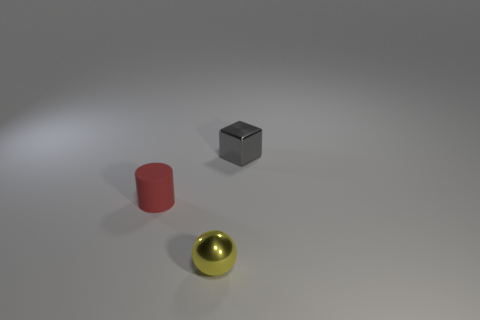Add 2 tiny metallic things. How many objects exist? 5 Subtract all balls. How many objects are left? 2 Subtract all large rubber blocks. Subtract all red things. How many objects are left? 2 Add 1 blocks. How many blocks are left? 2 Add 1 yellow shiny objects. How many yellow shiny objects exist? 2 Subtract 1 yellow balls. How many objects are left? 2 